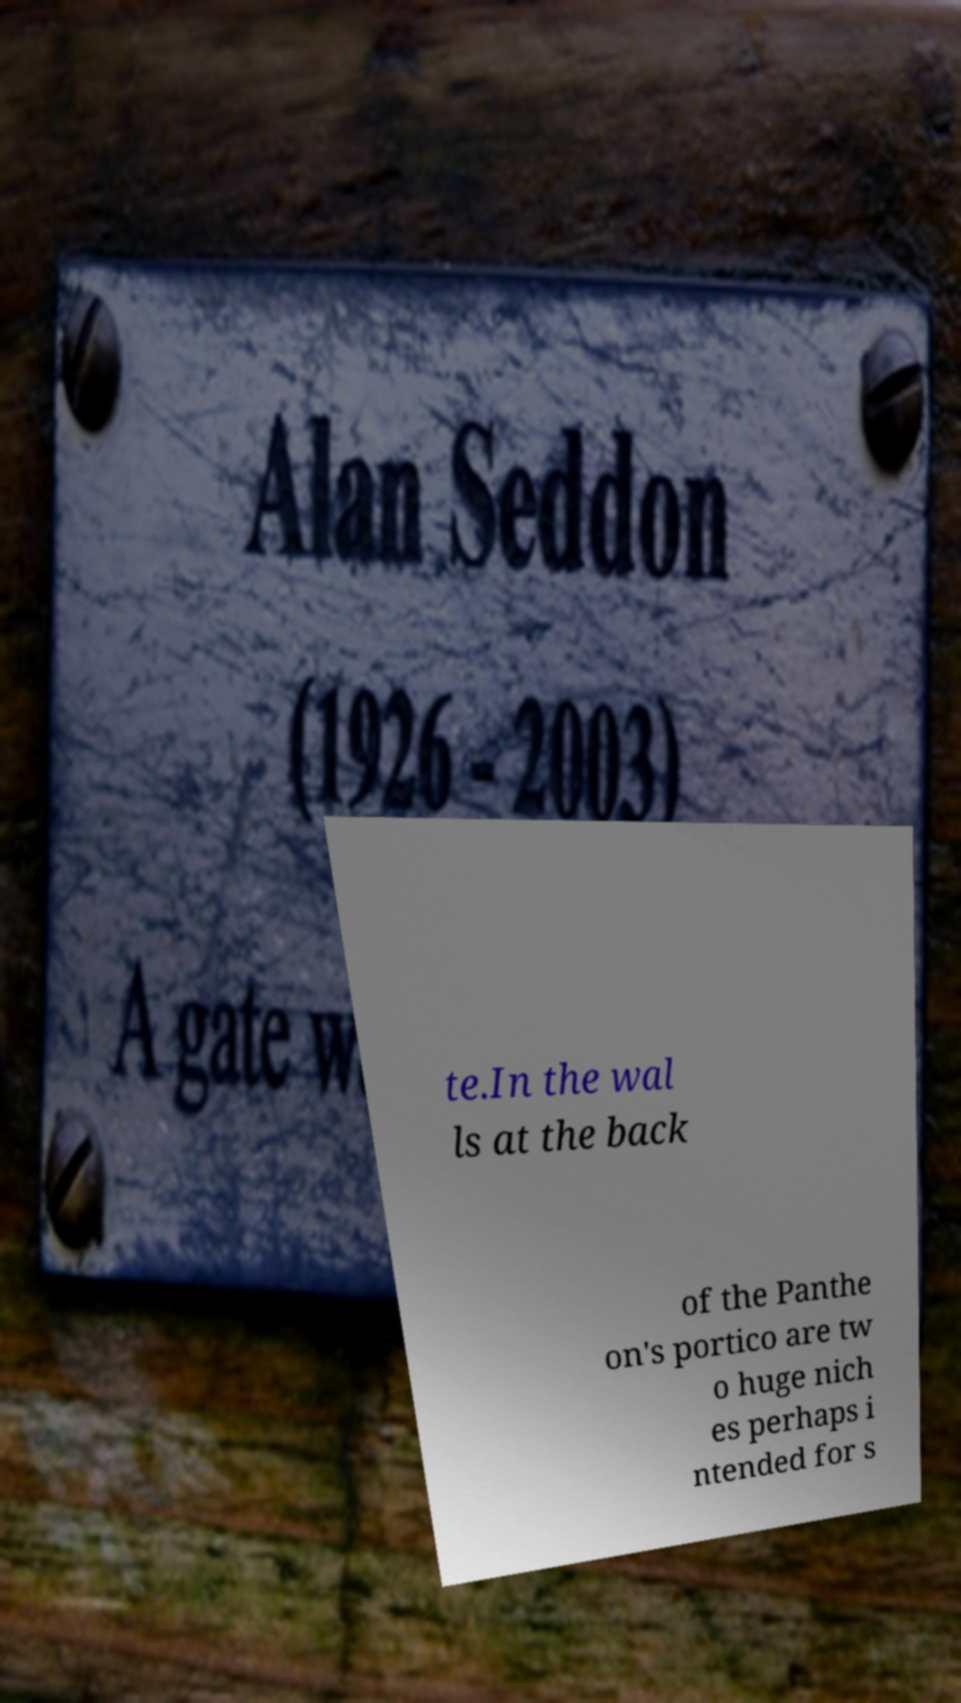Can you accurately transcribe the text from the provided image for me? te.In the wal ls at the back of the Panthe on's portico are tw o huge nich es perhaps i ntended for s 